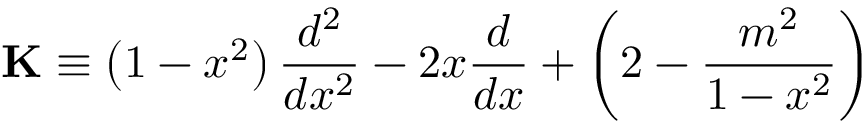<formula> <loc_0><loc_0><loc_500><loc_500>K \equiv \left ( 1 - x ^ { 2 } \right ) \frac { d ^ { 2 } } { d x ^ { 2 } } - 2 x \frac { d } { d x } + \left ( 2 - \frac { m ^ { 2 } } { 1 - x ^ { 2 } } \right )</formula> 